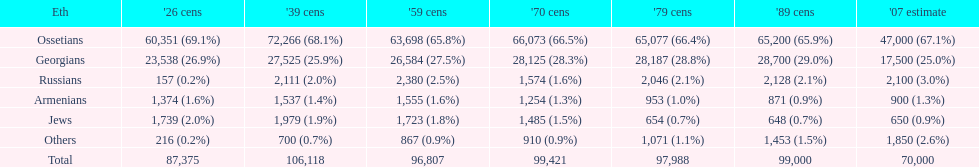What ethnicity is at the top? Ossetians. 